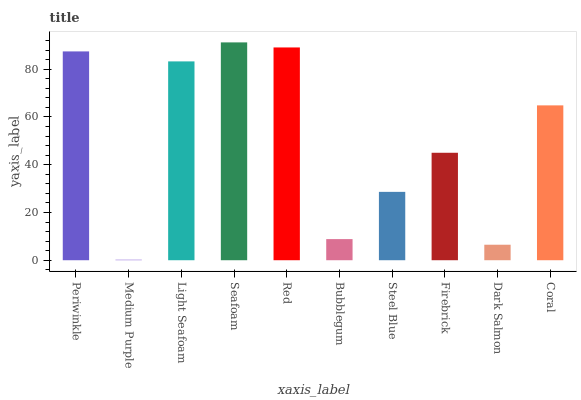Is Medium Purple the minimum?
Answer yes or no. Yes. Is Seafoam the maximum?
Answer yes or no. Yes. Is Light Seafoam the minimum?
Answer yes or no. No. Is Light Seafoam the maximum?
Answer yes or no. No. Is Light Seafoam greater than Medium Purple?
Answer yes or no. Yes. Is Medium Purple less than Light Seafoam?
Answer yes or no. Yes. Is Medium Purple greater than Light Seafoam?
Answer yes or no. No. Is Light Seafoam less than Medium Purple?
Answer yes or no. No. Is Coral the high median?
Answer yes or no. Yes. Is Firebrick the low median?
Answer yes or no. Yes. Is Red the high median?
Answer yes or no. No. Is Medium Purple the low median?
Answer yes or no. No. 